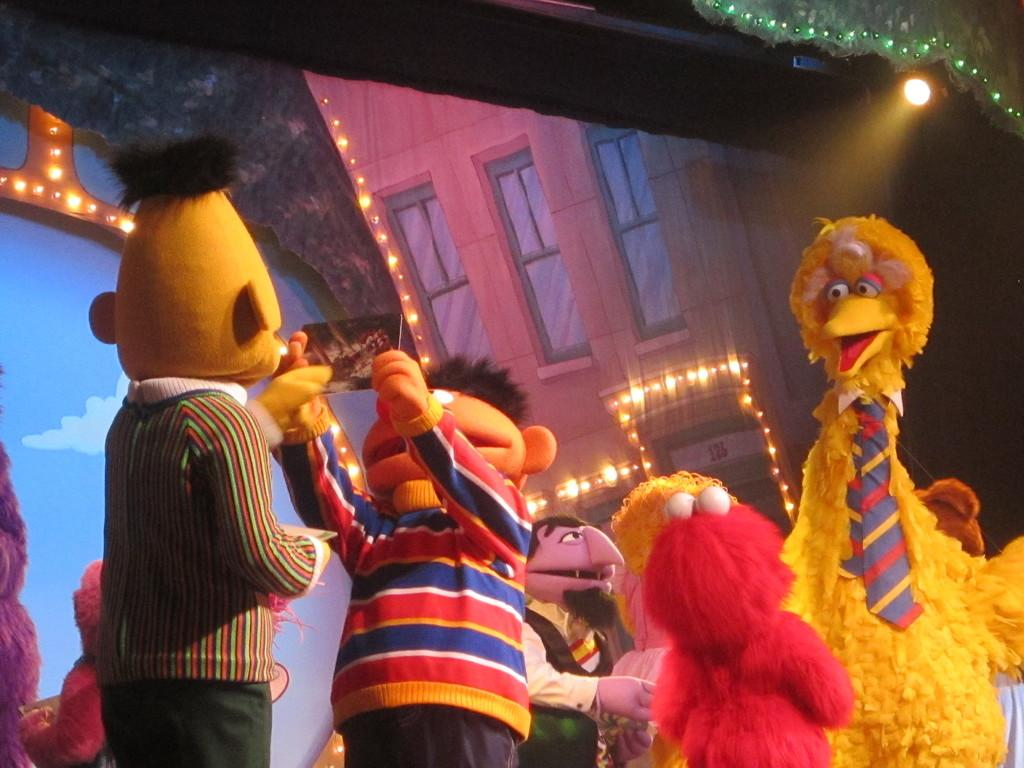What can be seen on the stage in the image? There are different toys on the stage in the image. What else is present in the image besides the toys on the stage? There are banners in the image. Can you describe the lighting in the image? There are lights on the roof in the image. What type of kettle is being used to prepare tea for the audience in the image? There is no kettle present in the image; it features toys on a stage with banners and lights. 